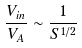<formula> <loc_0><loc_0><loc_500><loc_500>\frac { V _ { i n } } { V _ { A } } \sim \frac { 1 } { S ^ { 1 / 2 } }</formula> 